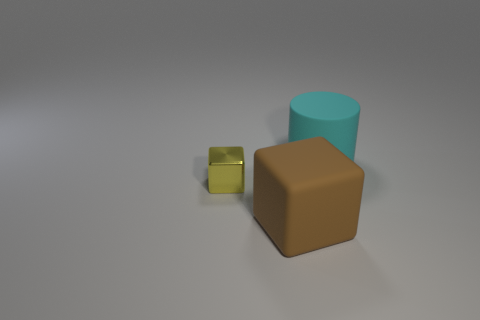Subtract all yellow blocks. How many blocks are left? 1 Subtract 1 blocks. How many blocks are left? 1 Add 2 small yellow blocks. How many objects exist? 5 Subtract 0 yellow spheres. How many objects are left? 3 Subtract all blocks. How many objects are left? 1 Subtract all yellow blocks. Subtract all brown balls. How many blocks are left? 1 Subtract all yellow balls. How many red cylinders are left? 0 Subtract all small rubber objects. Subtract all big brown matte cubes. How many objects are left? 2 Add 1 big brown matte objects. How many big brown matte objects are left? 2 Add 3 brown rubber cubes. How many brown rubber cubes exist? 4 